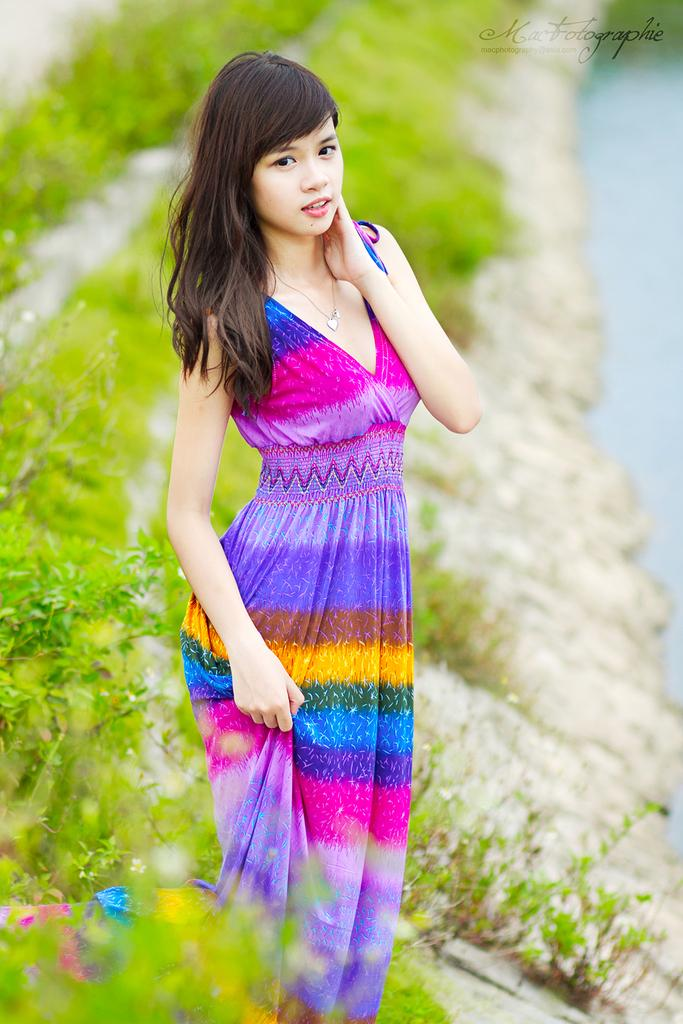What is the main subject of the image? There is a lady standing in the center of the image. Can you describe the background of the image? There are plants in the background of the image. How many donkeys can be seen in the image? There are no donkeys present in the image. What is the lady's territory in the image? The concept of territory does not apply to the lady in the image, as it is not a characteristic of people in photographs. 